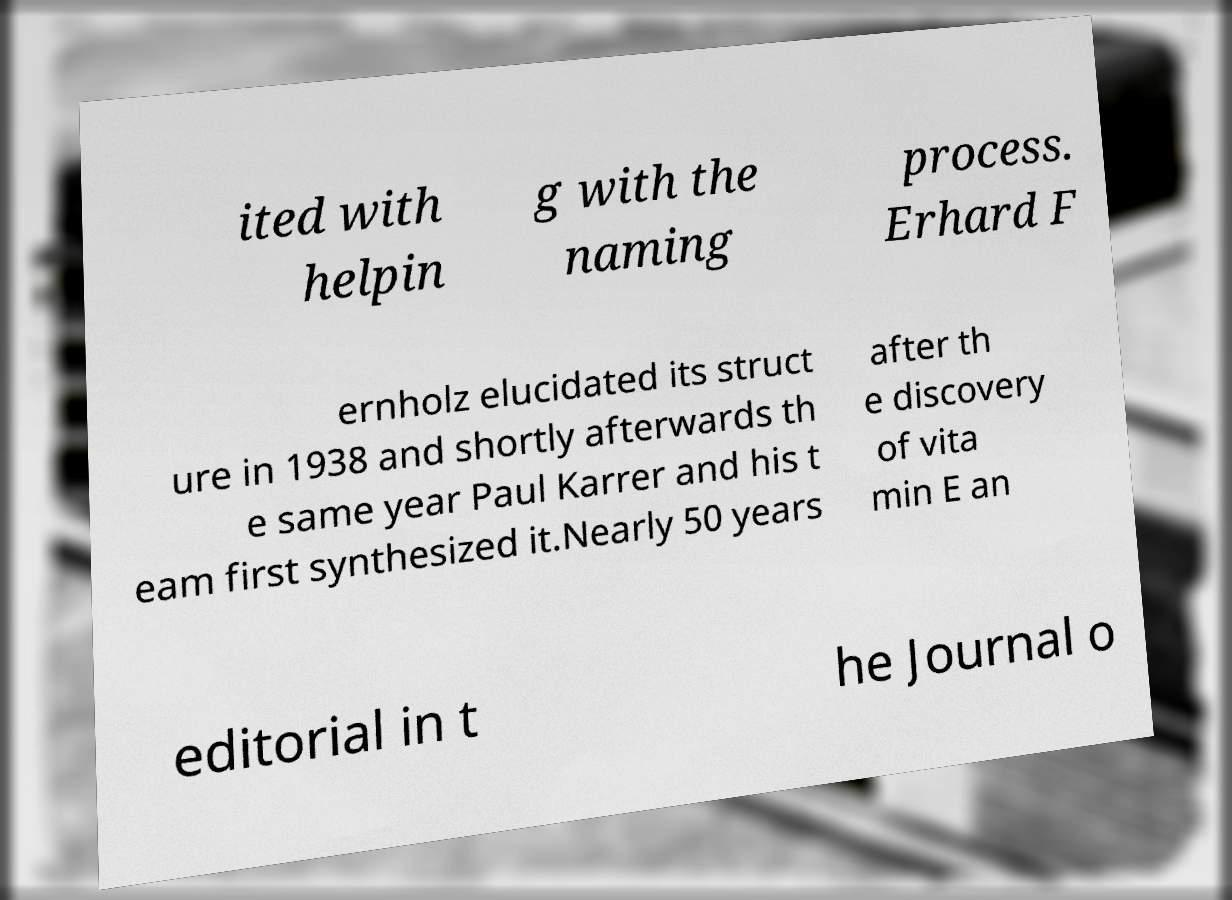Could you extract and type out the text from this image? ited with helpin g with the naming process. Erhard F ernholz elucidated its struct ure in 1938 and shortly afterwards th e same year Paul Karrer and his t eam first synthesized it.Nearly 50 years after th e discovery of vita min E an editorial in t he Journal o 